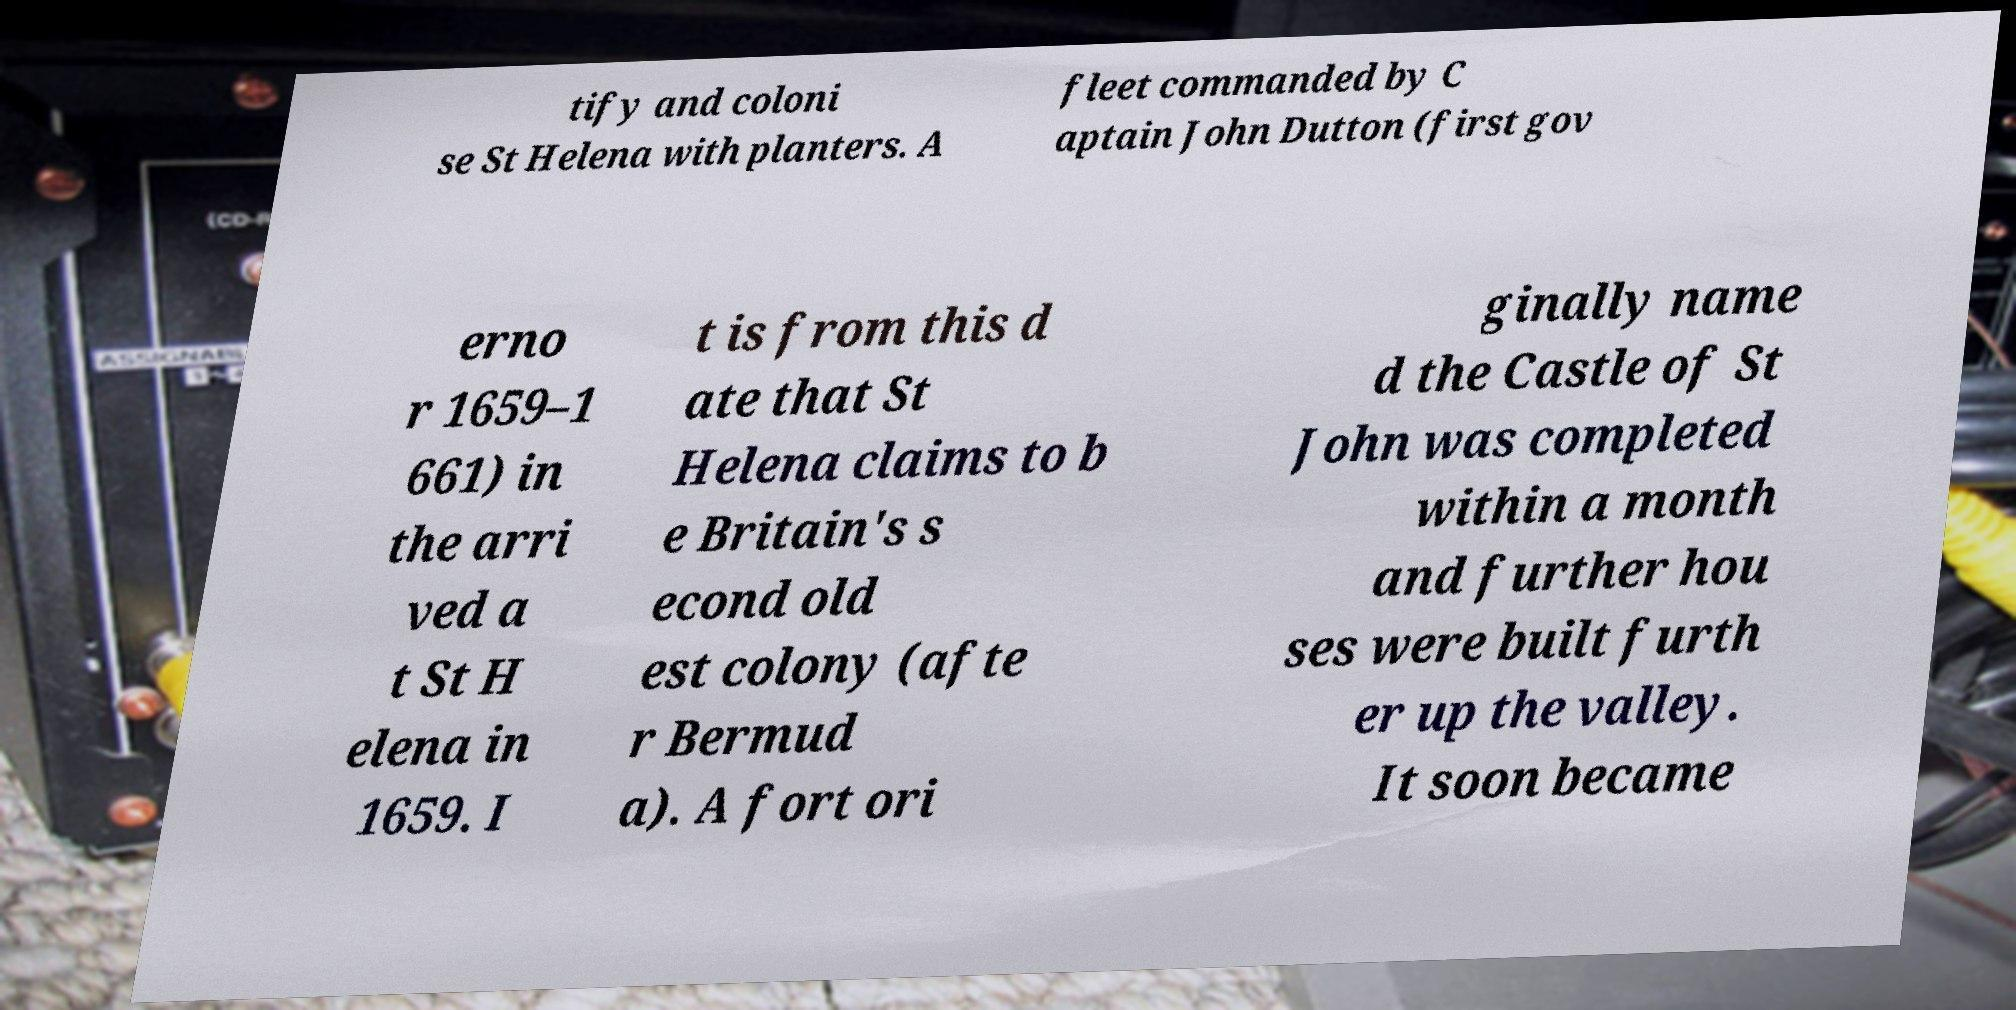Could you extract and type out the text from this image? tify and coloni se St Helena with planters. A fleet commanded by C aptain John Dutton (first gov erno r 1659–1 661) in the arri ved a t St H elena in 1659. I t is from this d ate that St Helena claims to b e Britain's s econd old est colony (afte r Bermud a). A fort ori ginally name d the Castle of St John was completed within a month and further hou ses were built furth er up the valley. It soon became 